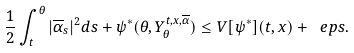<formula> <loc_0><loc_0><loc_500><loc_500>\frac { 1 } { 2 } \int _ { t } ^ { \theta } | \overline { \alpha } _ { s } | ^ { 2 } d s + \psi ^ { * } ( \theta , Y ^ { t , x , \overline { \alpha } } _ { \theta } ) \leq V [ \psi ^ { * } ] ( t , x ) + \ e p s .</formula> 